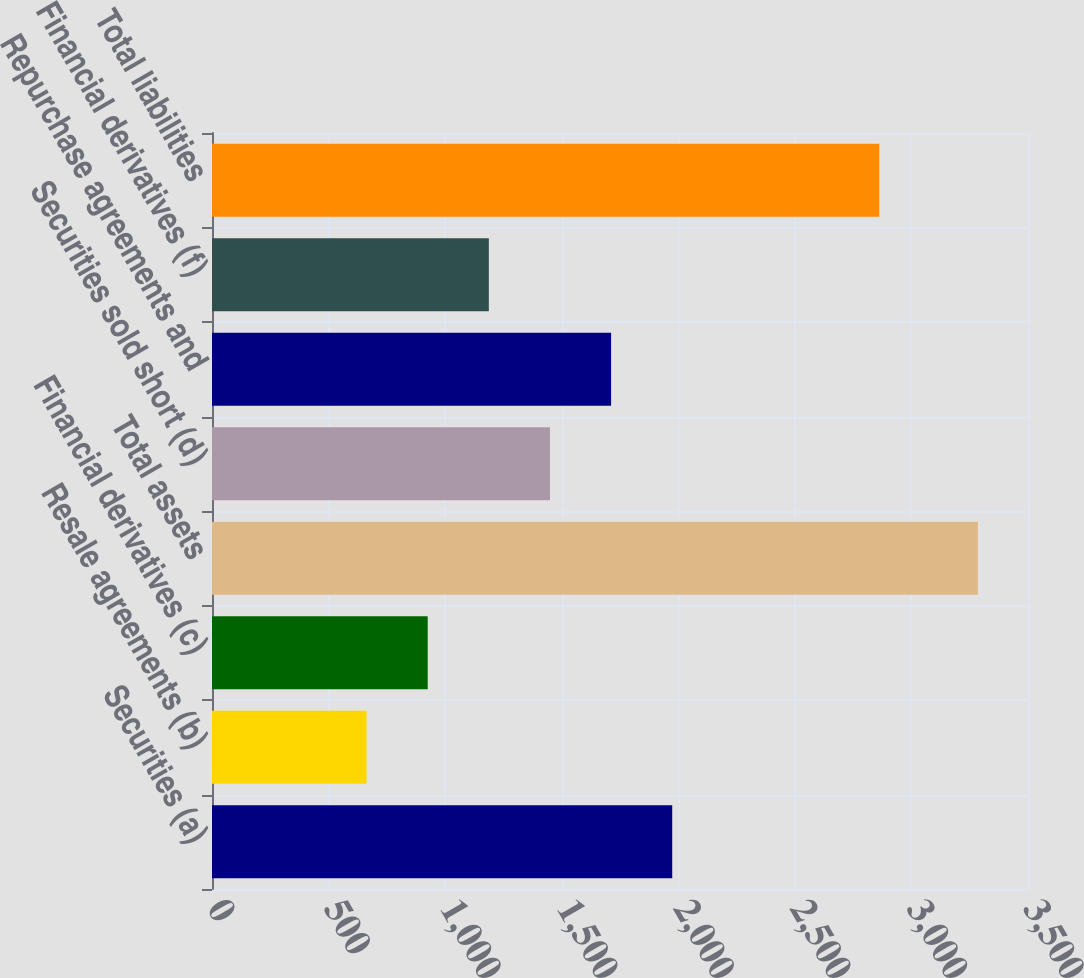Convert chart to OTSL. <chart><loc_0><loc_0><loc_500><loc_500><bar_chart><fcel>Securities (a)<fcel>Resale agreements (b)<fcel>Financial derivatives (c)<fcel>Total assets<fcel>Securities sold short (d)<fcel>Repurchase agreements and<fcel>Financial derivatives (f)<fcel>Total liabilities<nl><fcel>1974<fcel>663<fcel>925.2<fcel>3285<fcel>1449.6<fcel>1711.8<fcel>1187.4<fcel>2862<nl></chart> 